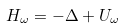<formula> <loc_0><loc_0><loc_500><loc_500>H _ { \omega } = - \Delta + U _ { \omega }</formula> 